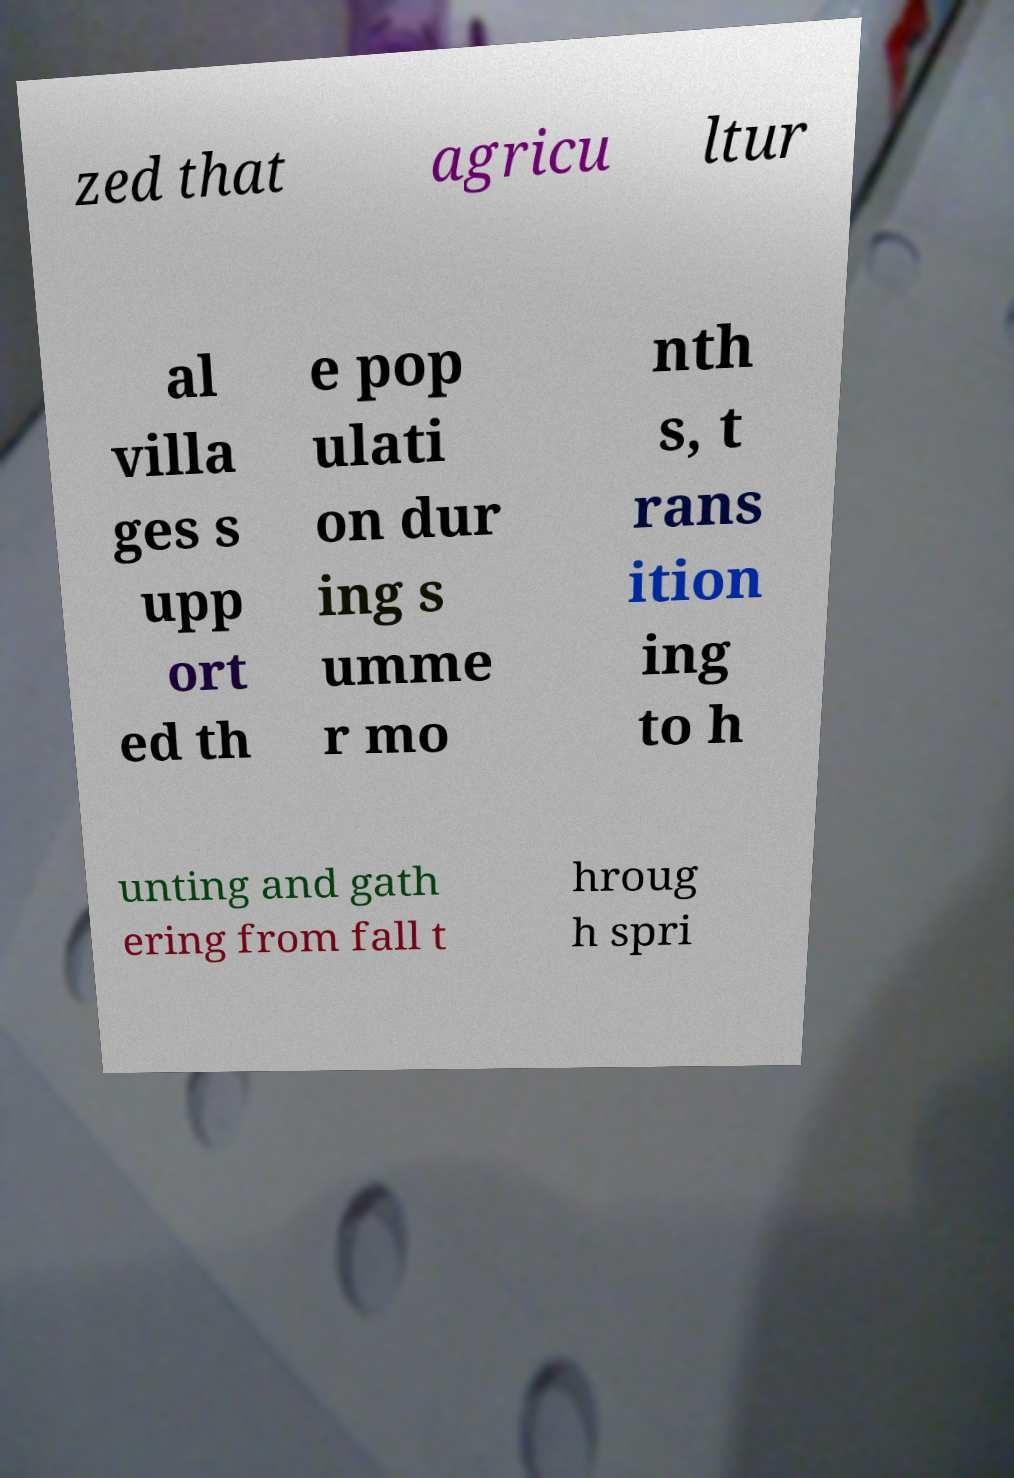Could you assist in decoding the text presented in this image and type it out clearly? zed that agricu ltur al villa ges s upp ort ed th e pop ulati on dur ing s umme r mo nth s, t rans ition ing to h unting and gath ering from fall t hroug h spri 